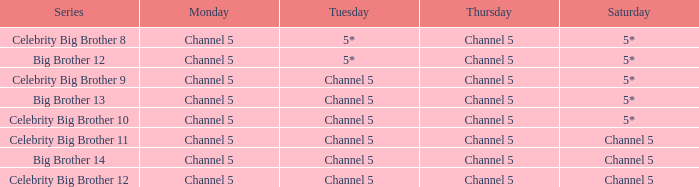Which program is scheduled on channel 5 for saturday airings? Celebrity Big Brother 11, Big Brother 14, Celebrity Big Brother 12. 